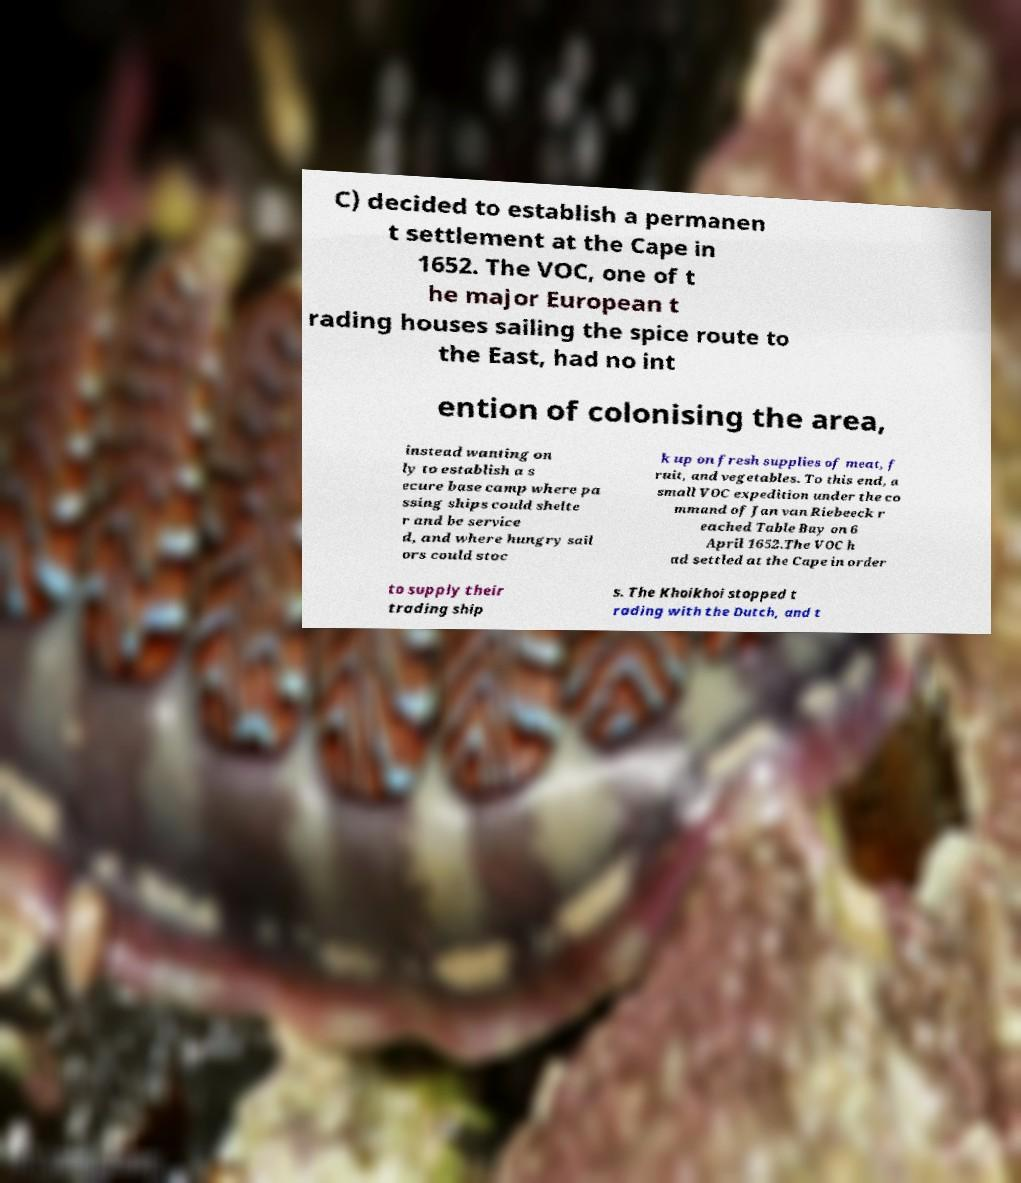Can you accurately transcribe the text from the provided image for me? C) decided to establish a permanen t settlement at the Cape in 1652. The VOC, one of t he major European t rading houses sailing the spice route to the East, had no int ention of colonising the area, instead wanting on ly to establish a s ecure base camp where pa ssing ships could shelte r and be service d, and where hungry sail ors could stoc k up on fresh supplies of meat, f ruit, and vegetables. To this end, a small VOC expedition under the co mmand of Jan van Riebeeck r eached Table Bay on 6 April 1652.The VOC h ad settled at the Cape in order to supply their trading ship s. The Khoikhoi stopped t rading with the Dutch, and t 